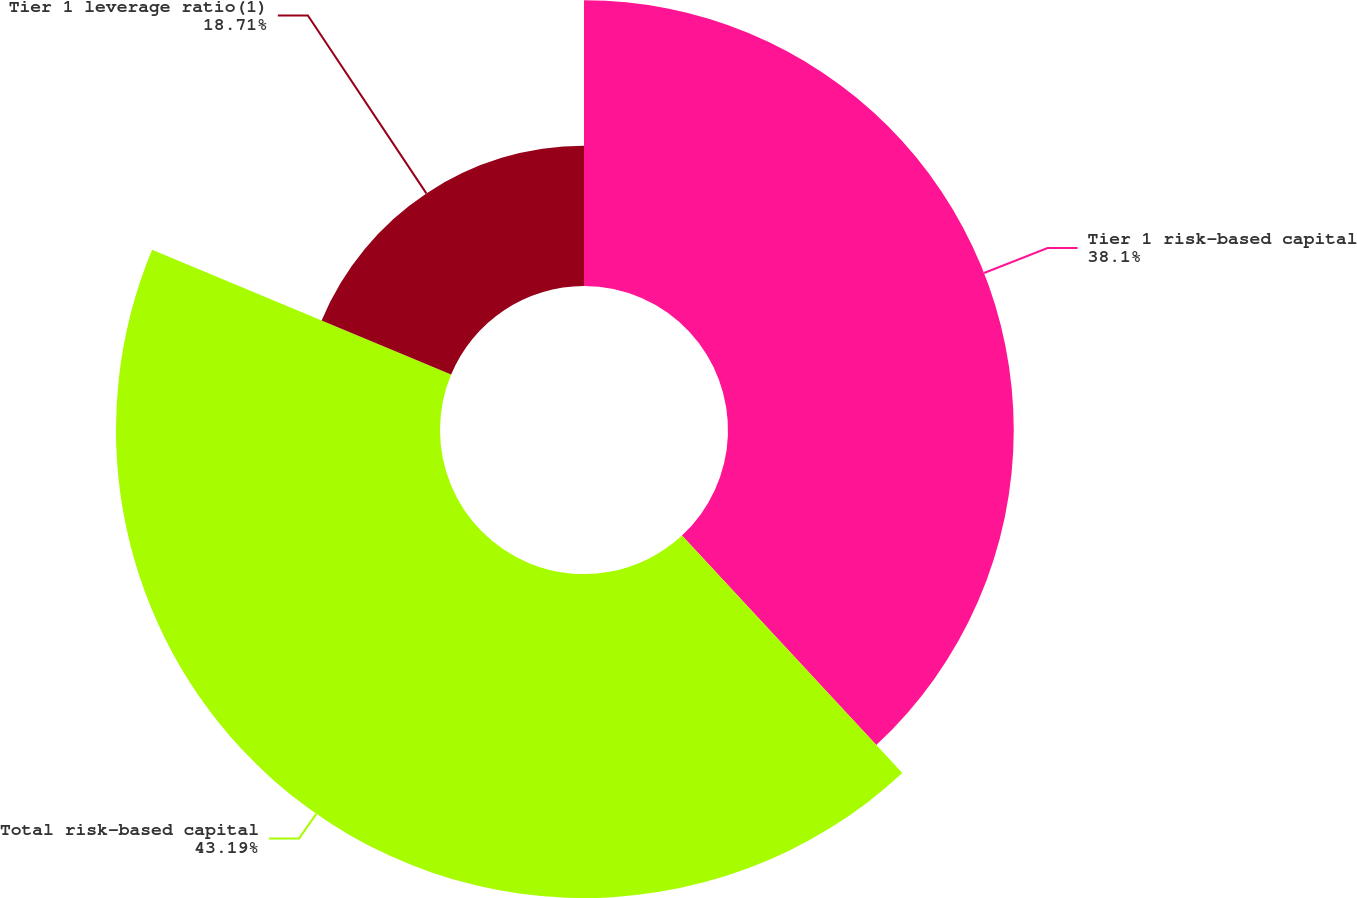Convert chart to OTSL. <chart><loc_0><loc_0><loc_500><loc_500><pie_chart><fcel>Tier 1 risk-based capital<fcel>Total risk-based capital<fcel>Tier 1 leverage ratio(1)<nl><fcel>38.1%<fcel>43.2%<fcel>18.71%<nl></chart> 